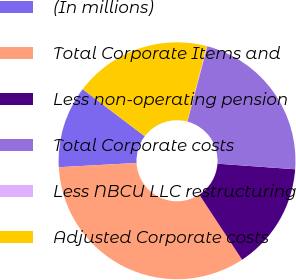Convert chart. <chart><loc_0><loc_0><loc_500><loc_500><pie_chart><fcel>(In millions)<fcel>Total Corporate Items and<fcel>Less non-operating pension<fcel>Total Corporate costs<fcel>Less NBCU LLC restructuring<fcel>Adjusted Corporate costs<nl><fcel>11.2%<fcel>33.39%<fcel>14.6%<fcel>22.03%<fcel>0.09%<fcel>18.7%<nl></chart> 